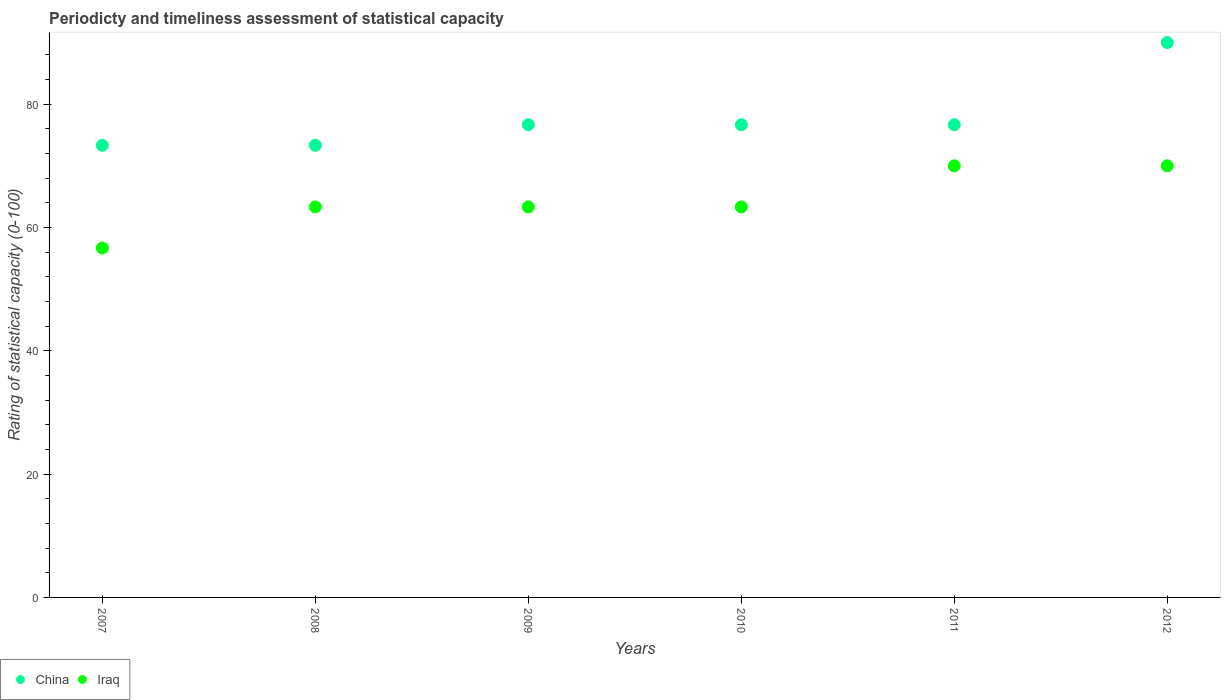How many different coloured dotlines are there?
Ensure brevity in your answer.  2. Across all years, what is the maximum rating of statistical capacity in Iraq?
Offer a terse response. 70. Across all years, what is the minimum rating of statistical capacity in China?
Provide a short and direct response. 73.33. In which year was the rating of statistical capacity in China maximum?
Offer a terse response. 2012. What is the total rating of statistical capacity in Iraq in the graph?
Offer a terse response. 386.67. What is the difference between the rating of statistical capacity in Iraq in 2008 and that in 2011?
Offer a very short reply. -6.67. What is the difference between the rating of statistical capacity in China in 2007 and the rating of statistical capacity in Iraq in 2008?
Offer a terse response. 10. What is the average rating of statistical capacity in China per year?
Offer a terse response. 77.78. In the year 2007, what is the difference between the rating of statistical capacity in Iraq and rating of statistical capacity in China?
Ensure brevity in your answer.  -16.67. What is the ratio of the rating of statistical capacity in China in 2008 to that in 2009?
Your response must be concise. 0.96. Is the difference between the rating of statistical capacity in Iraq in 2008 and 2011 greater than the difference between the rating of statistical capacity in China in 2008 and 2011?
Your answer should be very brief. No. What is the difference between the highest and the lowest rating of statistical capacity in China?
Make the answer very short. 16.67. In how many years, is the rating of statistical capacity in Iraq greater than the average rating of statistical capacity in Iraq taken over all years?
Keep it short and to the point. 2. Is the sum of the rating of statistical capacity in China in 2010 and 2012 greater than the maximum rating of statistical capacity in Iraq across all years?
Provide a succinct answer. Yes. Does the rating of statistical capacity in China monotonically increase over the years?
Offer a terse response. No. Is the rating of statistical capacity in Iraq strictly less than the rating of statistical capacity in China over the years?
Provide a short and direct response. Yes. How many dotlines are there?
Ensure brevity in your answer.  2. What is the difference between two consecutive major ticks on the Y-axis?
Offer a terse response. 20. Does the graph contain any zero values?
Provide a succinct answer. No. Does the graph contain grids?
Give a very brief answer. No. Where does the legend appear in the graph?
Offer a very short reply. Bottom left. How many legend labels are there?
Ensure brevity in your answer.  2. How are the legend labels stacked?
Offer a very short reply. Horizontal. What is the title of the graph?
Make the answer very short. Periodicty and timeliness assessment of statistical capacity. What is the label or title of the X-axis?
Your response must be concise. Years. What is the label or title of the Y-axis?
Ensure brevity in your answer.  Rating of statistical capacity (0-100). What is the Rating of statistical capacity (0-100) in China in 2007?
Provide a short and direct response. 73.33. What is the Rating of statistical capacity (0-100) of Iraq in 2007?
Offer a terse response. 56.67. What is the Rating of statistical capacity (0-100) of China in 2008?
Provide a short and direct response. 73.33. What is the Rating of statistical capacity (0-100) in Iraq in 2008?
Offer a very short reply. 63.33. What is the Rating of statistical capacity (0-100) in China in 2009?
Provide a succinct answer. 76.67. What is the Rating of statistical capacity (0-100) in Iraq in 2009?
Your answer should be compact. 63.33. What is the Rating of statistical capacity (0-100) of China in 2010?
Offer a terse response. 76.67. What is the Rating of statistical capacity (0-100) in Iraq in 2010?
Give a very brief answer. 63.33. What is the Rating of statistical capacity (0-100) in China in 2011?
Keep it short and to the point. 76.67. What is the Rating of statistical capacity (0-100) of Iraq in 2011?
Keep it short and to the point. 70. What is the Rating of statistical capacity (0-100) of China in 2012?
Provide a succinct answer. 90. Across all years, what is the minimum Rating of statistical capacity (0-100) in China?
Offer a very short reply. 73.33. Across all years, what is the minimum Rating of statistical capacity (0-100) in Iraq?
Your answer should be very brief. 56.67. What is the total Rating of statistical capacity (0-100) in China in the graph?
Your answer should be very brief. 466.67. What is the total Rating of statistical capacity (0-100) in Iraq in the graph?
Your answer should be very brief. 386.67. What is the difference between the Rating of statistical capacity (0-100) in Iraq in 2007 and that in 2008?
Offer a terse response. -6.67. What is the difference between the Rating of statistical capacity (0-100) in China in 2007 and that in 2009?
Your answer should be compact. -3.33. What is the difference between the Rating of statistical capacity (0-100) of Iraq in 2007 and that in 2009?
Offer a very short reply. -6.67. What is the difference between the Rating of statistical capacity (0-100) in China in 2007 and that in 2010?
Ensure brevity in your answer.  -3.33. What is the difference between the Rating of statistical capacity (0-100) of Iraq in 2007 and that in 2010?
Provide a succinct answer. -6.67. What is the difference between the Rating of statistical capacity (0-100) in Iraq in 2007 and that in 2011?
Your answer should be very brief. -13.33. What is the difference between the Rating of statistical capacity (0-100) of China in 2007 and that in 2012?
Offer a terse response. -16.67. What is the difference between the Rating of statistical capacity (0-100) of Iraq in 2007 and that in 2012?
Provide a succinct answer. -13.33. What is the difference between the Rating of statistical capacity (0-100) in Iraq in 2008 and that in 2009?
Offer a very short reply. 0. What is the difference between the Rating of statistical capacity (0-100) in China in 2008 and that in 2011?
Provide a short and direct response. -3.33. What is the difference between the Rating of statistical capacity (0-100) in Iraq in 2008 and that in 2011?
Offer a very short reply. -6.67. What is the difference between the Rating of statistical capacity (0-100) of China in 2008 and that in 2012?
Provide a short and direct response. -16.67. What is the difference between the Rating of statistical capacity (0-100) of Iraq in 2008 and that in 2012?
Offer a very short reply. -6.67. What is the difference between the Rating of statistical capacity (0-100) in China in 2009 and that in 2010?
Your answer should be very brief. 0. What is the difference between the Rating of statistical capacity (0-100) in Iraq in 2009 and that in 2010?
Keep it short and to the point. 0. What is the difference between the Rating of statistical capacity (0-100) of Iraq in 2009 and that in 2011?
Your response must be concise. -6.67. What is the difference between the Rating of statistical capacity (0-100) of China in 2009 and that in 2012?
Give a very brief answer. -13.33. What is the difference between the Rating of statistical capacity (0-100) of Iraq in 2009 and that in 2012?
Offer a very short reply. -6.67. What is the difference between the Rating of statistical capacity (0-100) of Iraq in 2010 and that in 2011?
Ensure brevity in your answer.  -6.67. What is the difference between the Rating of statistical capacity (0-100) of China in 2010 and that in 2012?
Your response must be concise. -13.33. What is the difference between the Rating of statistical capacity (0-100) of Iraq in 2010 and that in 2012?
Your response must be concise. -6.67. What is the difference between the Rating of statistical capacity (0-100) of China in 2011 and that in 2012?
Ensure brevity in your answer.  -13.33. What is the difference between the Rating of statistical capacity (0-100) of China in 2007 and the Rating of statistical capacity (0-100) of Iraq in 2008?
Offer a very short reply. 10. What is the difference between the Rating of statistical capacity (0-100) in China in 2007 and the Rating of statistical capacity (0-100) in Iraq in 2010?
Your answer should be compact. 10. What is the difference between the Rating of statistical capacity (0-100) of China in 2007 and the Rating of statistical capacity (0-100) of Iraq in 2012?
Offer a very short reply. 3.33. What is the difference between the Rating of statistical capacity (0-100) of China in 2008 and the Rating of statistical capacity (0-100) of Iraq in 2009?
Offer a terse response. 10. What is the difference between the Rating of statistical capacity (0-100) in China in 2008 and the Rating of statistical capacity (0-100) in Iraq in 2010?
Your answer should be very brief. 10. What is the difference between the Rating of statistical capacity (0-100) in China in 2008 and the Rating of statistical capacity (0-100) in Iraq in 2011?
Offer a very short reply. 3.33. What is the difference between the Rating of statistical capacity (0-100) in China in 2008 and the Rating of statistical capacity (0-100) in Iraq in 2012?
Ensure brevity in your answer.  3.33. What is the difference between the Rating of statistical capacity (0-100) in China in 2009 and the Rating of statistical capacity (0-100) in Iraq in 2010?
Your answer should be very brief. 13.33. What is the difference between the Rating of statistical capacity (0-100) in China in 2009 and the Rating of statistical capacity (0-100) in Iraq in 2011?
Provide a short and direct response. 6.67. What is the difference between the Rating of statistical capacity (0-100) of China in 2010 and the Rating of statistical capacity (0-100) of Iraq in 2012?
Give a very brief answer. 6.67. What is the difference between the Rating of statistical capacity (0-100) in China in 2011 and the Rating of statistical capacity (0-100) in Iraq in 2012?
Your answer should be compact. 6.67. What is the average Rating of statistical capacity (0-100) of China per year?
Provide a short and direct response. 77.78. What is the average Rating of statistical capacity (0-100) in Iraq per year?
Your answer should be very brief. 64.44. In the year 2007, what is the difference between the Rating of statistical capacity (0-100) in China and Rating of statistical capacity (0-100) in Iraq?
Your answer should be very brief. 16.67. In the year 2009, what is the difference between the Rating of statistical capacity (0-100) in China and Rating of statistical capacity (0-100) in Iraq?
Your response must be concise. 13.33. In the year 2010, what is the difference between the Rating of statistical capacity (0-100) in China and Rating of statistical capacity (0-100) in Iraq?
Your response must be concise. 13.33. In the year 2011, what is the difference between the Rating of statistical capacity (0-100) of China and Rating of statistical capacity (0-100) of Iraq?
Give a very brief answer. 6.67. In the year 2012, what is the difference between the Rating of statistical capacity (0-100) of China and Rating of statistical capacity (0-100) of Iraq?
Your answer should be very brief. 20. What is the ratio of the Rating of statistical capacity (0-100) in Iraq in 2007 to that in 2008?
Your answer should be very brief. 0.89. What is the ratio of the Rating of statistical capacity (0-100) in China in 2007 to that in 2009?
Your answer should be very brief. 0.96. What is the ratio of the Rating of statistical capacity (0-100) of Iraq in 2007 to that in 2009?
Offer a very short reply. 0.89. What is the ratio of the Rating of statistical capacity (0-100) in China in 2007 to that in 2010?
Your answer should be compact. 0.96. What is the ratio of the Rating of statistical capacity (0-100) in Iraq in 2007 to that in 2010?
Give a very brief answer. 0.89. What is the ratio of the Rating of statistical capacity (0-100) in China in 2007 to that in 2011?
Your answer should be very brief. 0.96. What is the ratio of the Rating of statistical capacity (0-100) in Iraq in 2007 to that in 2011?
Offer a terse response. 0.81. What is the ratio of the Rating of statistical capacity (0-100) of China in 2007 to that in 2012?
Provide a succinct answer. 0.81. What is the ratio of the Rating of statistical capacity (0-100) in Iraq in 2007 to that in 2012?
Keep it short and to the point. 0.81. What is the ratio of the Rating of statistical capacity (0-100) of China in 2008 to that in 2009?
Ensure brevity in your answer.  0.96. What is the ratio of the Rating of statistical capacity (0-100) in China in 2008 to that in 2010?
Your answer should be very brief. 0.96. What is the ratio of the Rating of statistical capacity (0-100) of Iraq in 2008 to that in 2010?
Your response must be concise. 1. What is the ratio of the Rating of statistical capacity (0-100) in China in 2008 to that in 2011?
Your response must be concise. 0.96. What is the ratio of the Rating of statistical capacity (0-100) of Iraq in 2008 to that in 2011?
Your response must be concise. 0.9. What is the ratio of the Rating of statistical capacity (0-100) of China in 2008 to that in 2012?
Provide a short and direct response. 0.81. What is the ratio of the Rating of statistical capacity (0-100) of Iraq in 2008 to that in 2012?
Give a very brief answer. 0.9. What is the ratio of the Rating of statistical capacity (0-100) of Iraq in 2009 to that in 2010?
Keep it short and to the point. 1. What is the ratio of the Rating of statistical capacity (0-100) in China in 2009 to that in 2011?
Your response must be concise. 1. What is the ratio of the Rating of statistical capacity (0-100) in Iraq in 2009 to that in 2011?
Keep it short and to the point. 0.9. What is the ratio of the Rating of statistical capacity (0-100) of China in 2009 to that in 2012?
Offer a terse response. 0.85. What is the ratio of the Rating of statistical capacity (0-100) in Iraq in 2009 to that in 2012?
Ensure brevity in your answer.  0.9. What is the ratio of the Rating of statistical capacity (0-100) of Iraq in 2010 to that in 2011?
Provide a succinct answer. 0.9. What is the ratio of the Rating of statistical capacity (0-100) of China in 2010 to that in 2012?
Your answer should be very brief. 0.85. What is the ratio of the Rating of statistical capacity (0-100) in Iraq in 2010 to that in 2012?
Offer a terse response. 0.9. What is the ratio of the Rating of statistical capacity (0-100) of China in 2011 to that in 2012?
Provide a short and direct response. 0.85. What is the difference between the highest and the second highest Rating of statistical capacity (0-100) of China?
Ensure brevity in your answer.  13.33. What is the difference between the highest and the second highest Rating of statistical capacity (0-100) in Iraq?
Keep it short and to the point. 0. What is the difference between the highest and the lowest Rating of statistical capacity (0-100) in China?
Provide a short and direct response. 16.67. What is the difference between the highest and the lowest Rating of statistical capacity (0-100) in Iraq?
Give a very brief answer. 13.33. 